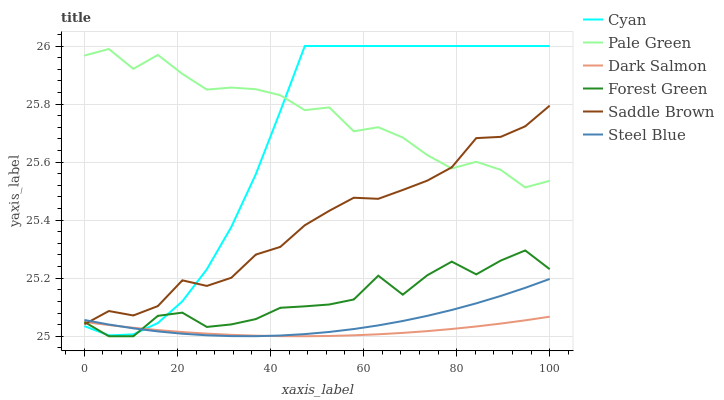Does Dark Salmon have the minimum area under the curve?
Answer yes or no. Yes. Does Pale Green have the maximum area under the curve?
Answer yes or no. Yes. Does Steel Blue have the minimum area under the curve?
Answer yes or no. No. Does Steel Blue have the maximum area under the curve?
Answer yes or no. No. Is Dark Salmon the smoothest?
Answer yes or no. Yes. Is Forest Green the roughest?
Answer yes or no. Yes. Is Steel Blue the smoothest?
Answer yes or no. No. Is Steel Blue the roughest?
Answer yes or no. No. Does Forest Green have the lowest value?
Answer yes or no. Yes. Does Steel Blue have the lowest value?
Answer yes or no. No. Does Cyan have the highest value?
Answer yes or no. Yes. Does Steel Blue have the highest value?
Answer yes or no. No. Is Forest Green less than Pale Green?
Answer yes or no. Yes. Is Pale Green greater than Steel Blue?
Answer yes or no. Yes. Does Forest Green intersect Dark Salmon?
Answer yes or no. Yes. Is Forest Green less than Dark Salmon?
Answer yes or no. No. Is Forest Green greater than Dark Salmon?
Answer yes or no. No. Does Forest Green intersect Pale Green?
Answer yes or no. No. 